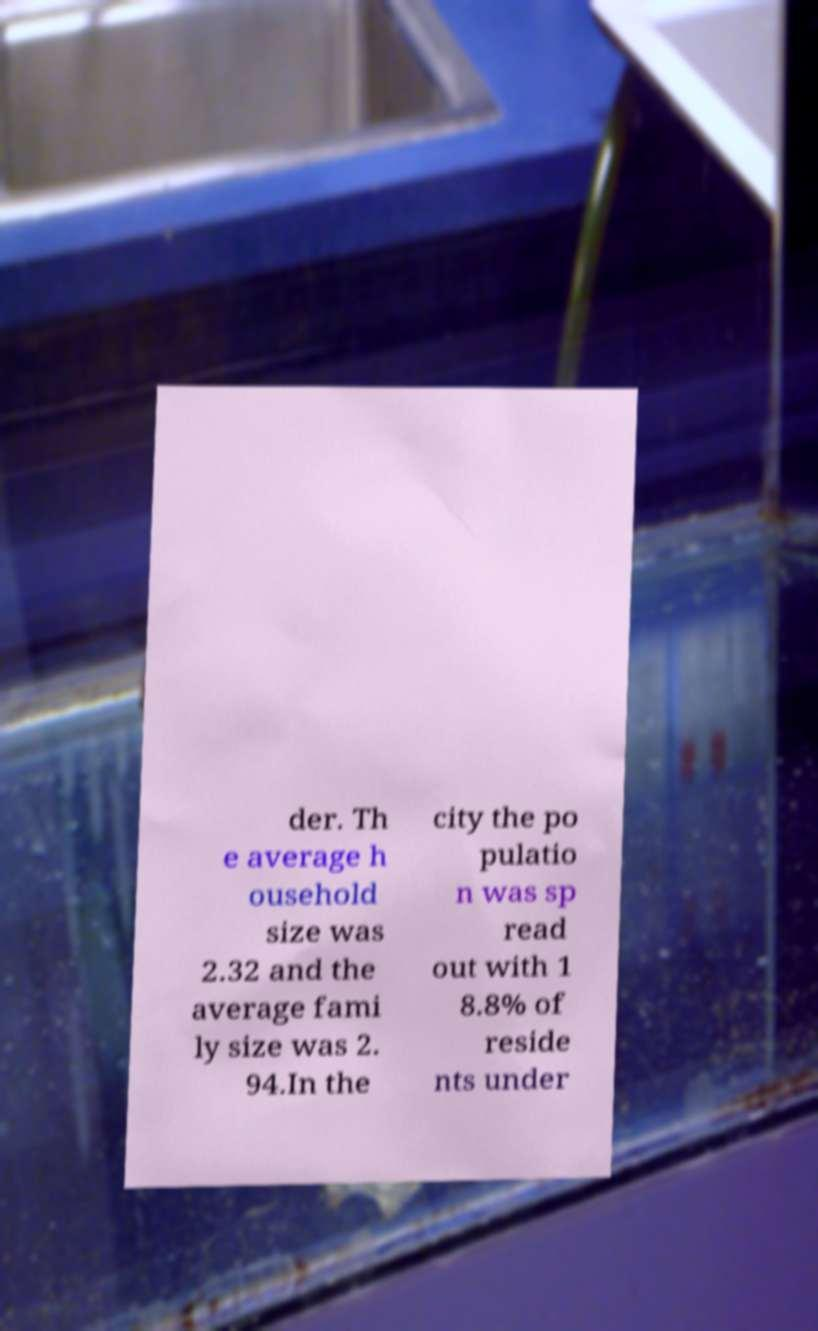Can you read and provide the text displayed in the image?This photo seems to have some interesting text. Can you extract and type it out for me? der. Th e average h ousehold size was 2.32 and the average fami ly size was 2. 94.In the city the po pulatio n was sp read out with 1 8.8% of reside nts under 